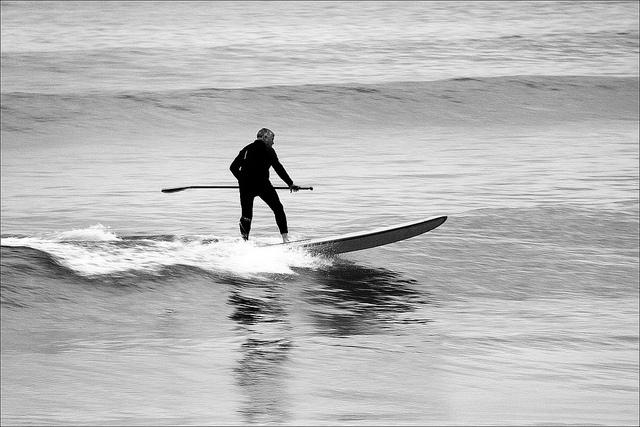What is the volatility of the wave?
Quick response, please. Low. Is the person preparing to jump?
Give a very brief answer. No. Is the man on a boat?
Give a very brief answer. No. What is in this person's hands?
Concise answer only. Paddle. Does the person have a paddle?
Answer briefly. Yes. 